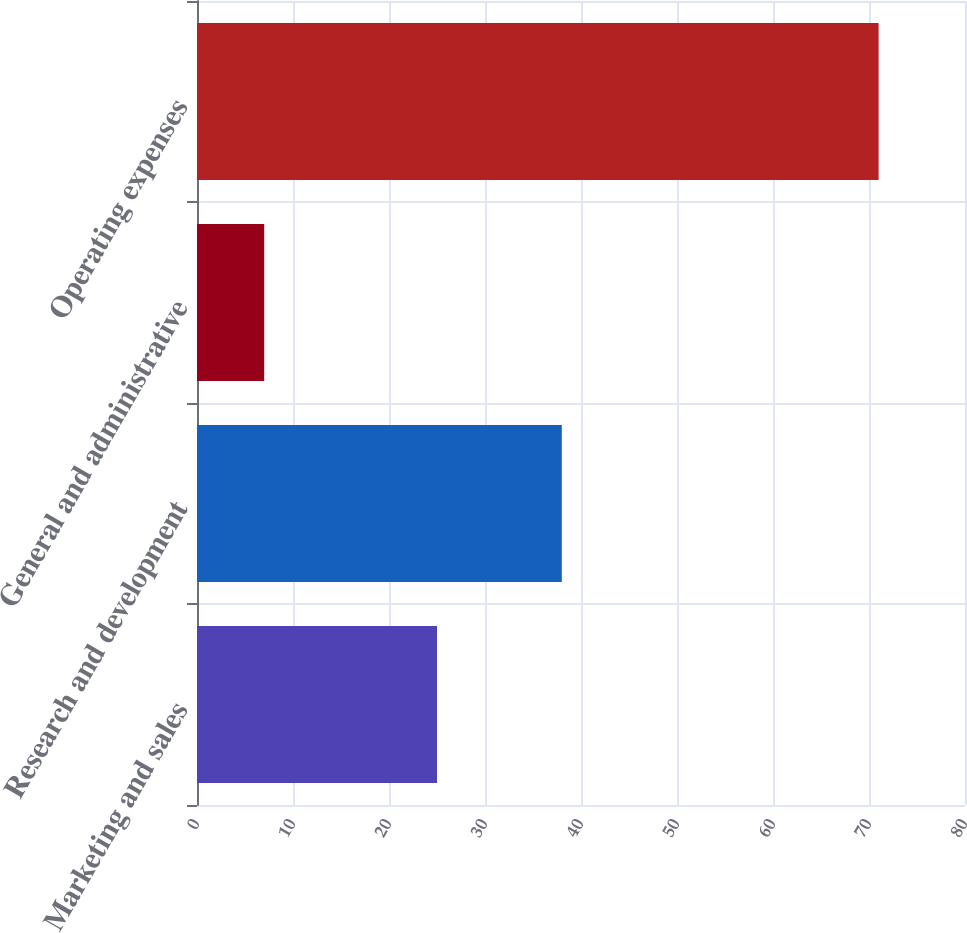Convert chart to OTSL. <chart><loc_0><loc_0><loc_500><loc_500><bar_chart><fcel>Marketing and sales<fcel>Research and development<fcel>General and administrative<fcel>Operating expenses<nl><fcel>25<fcel>38<fcel>7<fcel>71<nl></chart> 